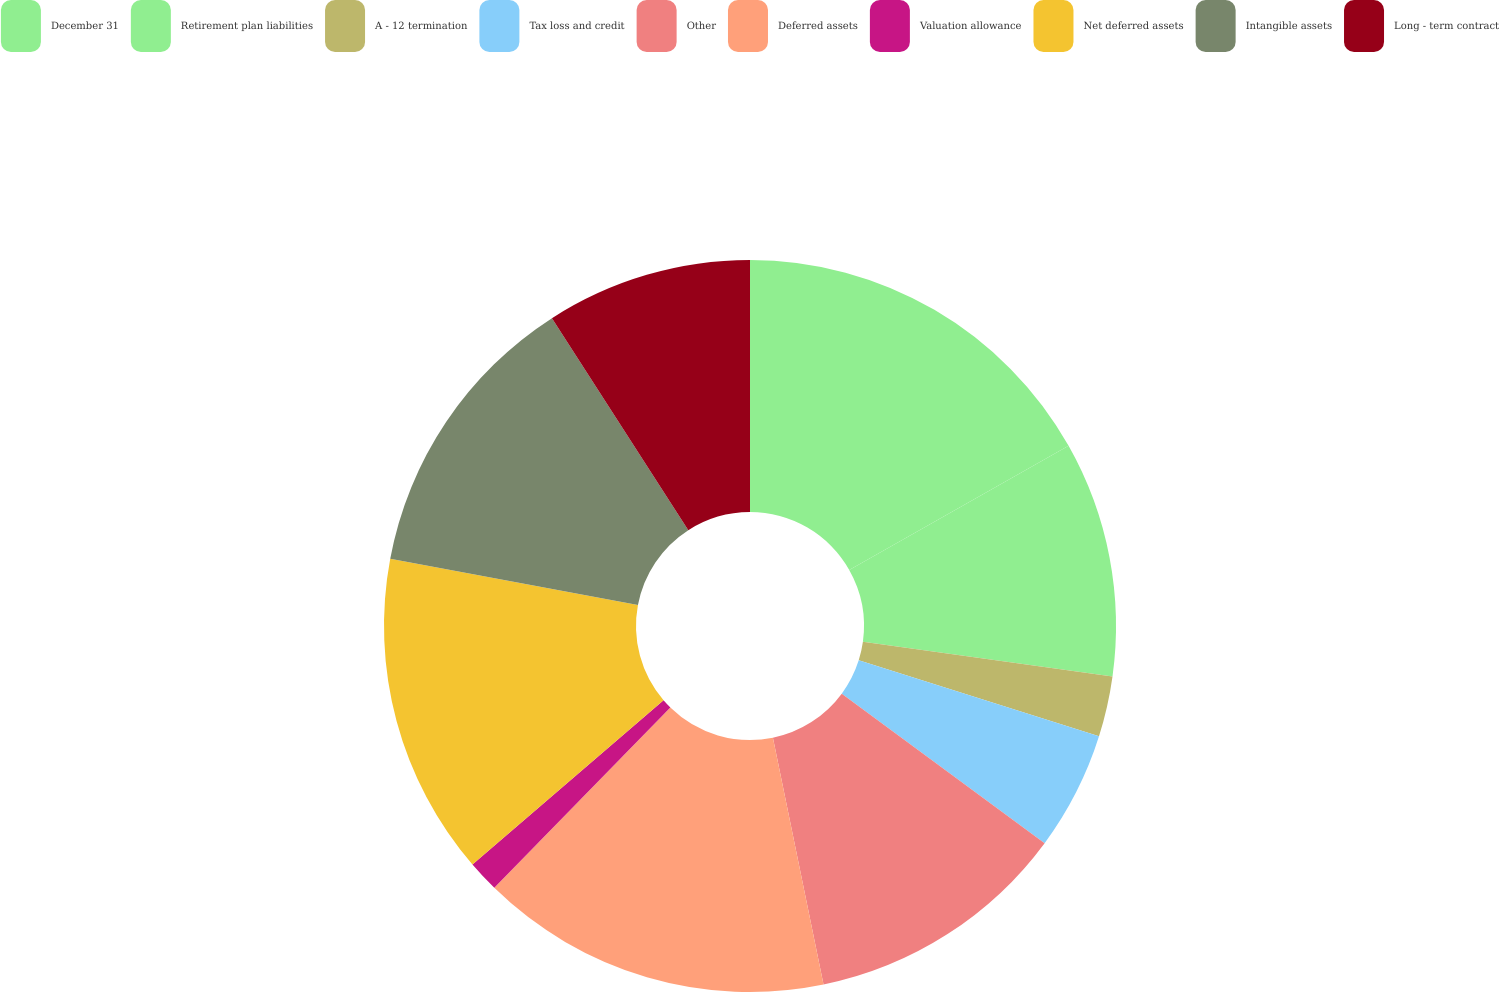<chart> <loc_0><loc_0><loc_500><loc_500><pie_chart><fcel>December 31<fcel>Retirement plan liabilities<fcel>A - 12 termination<fcel>Tax loss and credit<fcel>Other<fcel>Deferred assets<fcel>Valuation allowance<fcel>Net deferred assets<fcel>Intangible assets<fcel>Long - term contract<nl><fcel>16.81%<fcel>10.39%<fcel>2.67%<fcel>5.24%<fcel>11.67%<fcel>15.53%<fcel>1.39%<fcel>14.24%<fcel>12.96%<fcel>9.1%<nl></chart> 